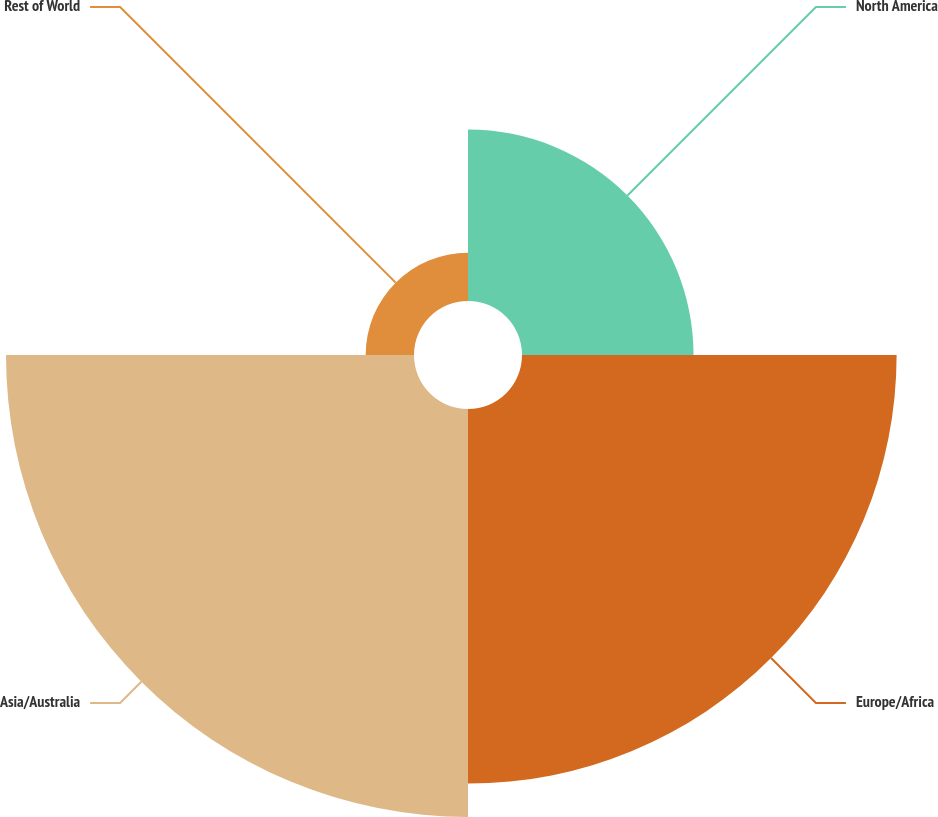Convert chart to OTSL. <chart><loc_0><loc_0><loc_500><loc_500><pie_chart><fcel>North America<fcel>Europe/Africa<fcel>Asia/Australia<fcel>Rest of World<nl><fcel>17.11%<fcel>37.37%<fcel>40.7%<fcel>4.82%<nl></chart> 